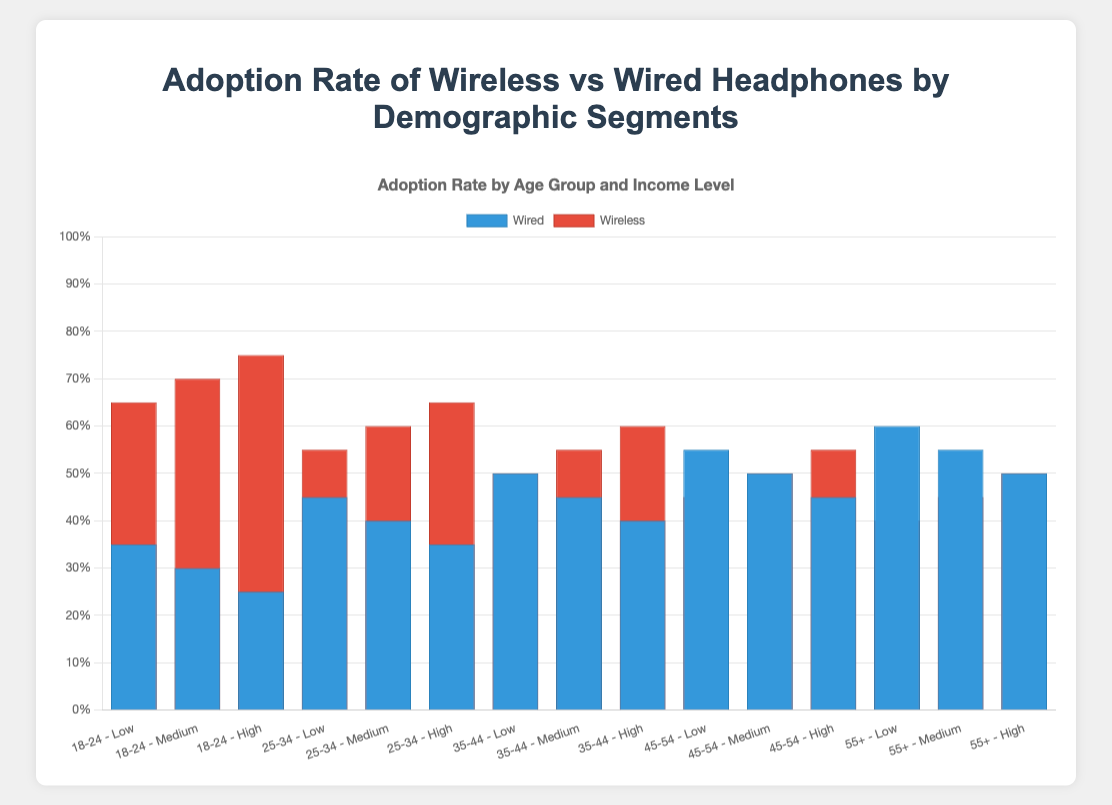Which age group has the highest adoption rate for wireless headphones? By examining the height of the red bars representing wireless headphones for each age group, the 18-24 age group shows the highest adoption rate at 65-75% across different income levels
Answer: 18-24 Which income level within the 25-34 age group prefers wireless headphones the most? Within the 25-34 age group, the income level represented by the highest red bar is "High" with a 65% adoption rate for wireless headphones
Answer: High Compare the adoption rates of wired headphones for the age group 45-54 across different income levels. For the 45-54 age group, the blue bars representing wired headphones show 55% for Low income, 50% for Medium income, and 45% for High income. The adoption rate decreases as income level increases
Answer: Low > Medium > High What's the average adoption rate of wired headphones for the age group 35-44? The wired headphone adoption rates for the 35-44 age group are 50% (Low), 45% (Medium), and 40% (High). The average is (50 + 45 + 40) / 3 = 45%
Answer: 45% Which demographic segment has the most balanced adoption rate between wired and wireless headphones? A balanced adoption rate would have similar blue and red bar heights. The 35-44 age group with Low income shows both wired and wireless at 50%
Answer: 35-44 Low income What is the difference in adoption rates between wireless and wired headphones for the age group 55+ with Medium income? The adoption rate for wired headphones is 55%, and for wireless, it is 45%. The difference is 55% - 45% = 10%
Answer: 10% Which income level within the 18-24 age group has the lowest adoption rate for wired headphones? Within the 18-24 age group, the lowest blue bar representing wired headphones corresponds to the "High" income level, with a 25% adoption rate
Answer: High What is the total adoption rate for all types of headphones for the age group 25-34 with Medium income? The total adoption rate is the sum of wired and wireless adoption rates for that segment: 40% (Wired) + 60% (Wireless) = 100%
Answer: 100% Compare the adoption rates between wired and wireless headphones for Low-income levels across all age groups. For Low-income across age groups, the blue bars (wired) and red bars (wireless) have these rates: 18-24 (Wired: 35%, Wireless: 65%), 25-34 (Wired: 45%, Wireless: 55%), 35-44 (Wired: 50%, Wireless: 50%), 45-54 (Wired: 55%, Wireless: 45%), 55+ (Wired: 60%, Wireless: 40%). The preference for wireless headphones decreases as age increases
Answer: 18-24: Wireless, 25-34: Wireless, 35-44: Equal, 45-54: Wired, 55+: Wired For the age group 55+, which type of headphones shows more consistent adoption rates across different income levels? For the 55+ age group, wired adoption rates are 60% (Low), 55% (Medium), and 50% (High), which are within a 10% range. Wireless adoption rates are 40% (Low), 45% (Medium), and 50% (High), which are also within a 10% range. Both types show similar consistency across income levels
Answer: Both types 